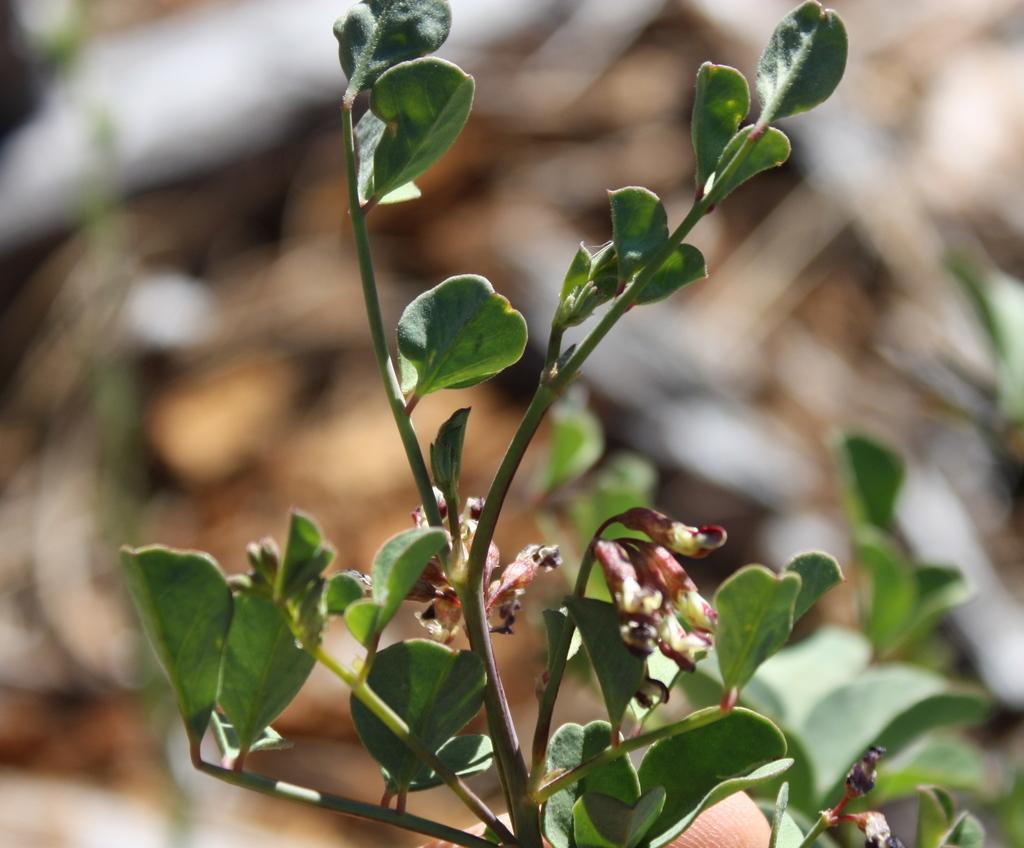What type of plant material can be seen in the image? There are leaves and stems in the image. Can you describe the background of the image? The background of the image is blurry. What type of seat is visible in the image? There is no seat present in the image; it features leaves and stems with a blurry background. How does the acoustics of the image affect the sound quality? The image does not have any sound or acoustics, as it is a still image featuring leaves, stems, and a blurry background. 